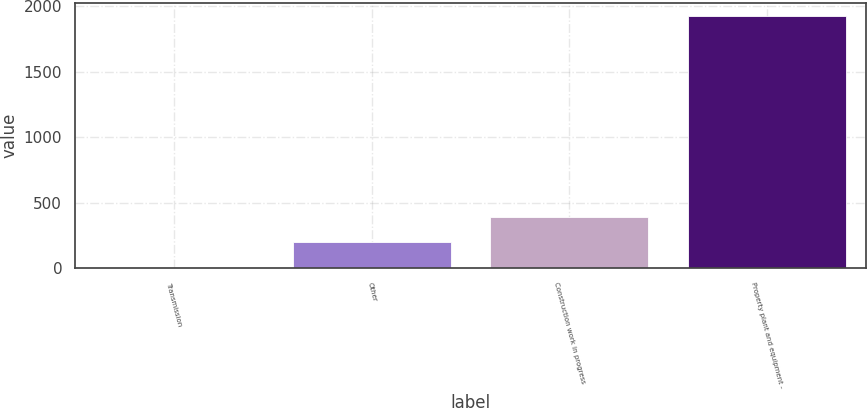Convert chart to OTSL. <chart><loc_0><loc_0><loc_500><loc_500><bar_chart><fcel>Transmission<fcel>Other<fcel>Construction work in progress<fcel>Property plant and equipment -<nl><fcel>5<fcel>197.2<fcel>389.4<fcel>1927<nl></chart> 